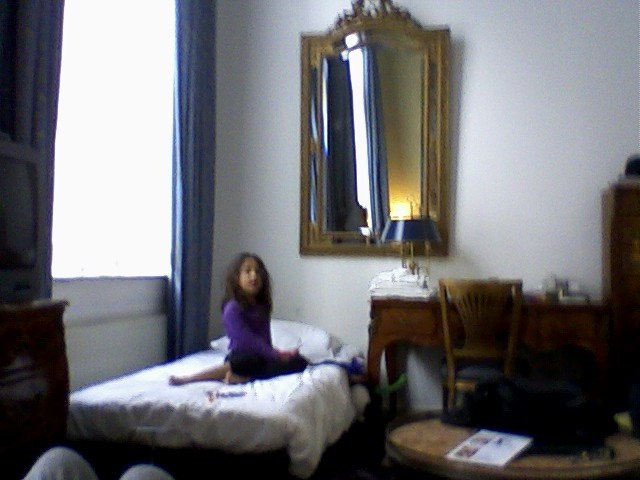Describe the objects in this image and their specific colors. I can see bed in black, lavender, gray, and darkgray tones, chair in black, maroon, and gray tones, people in black, gray, navy, and purple tones, backpack in black and navy tones, and tv in black, gray, and purple tones in this image. 